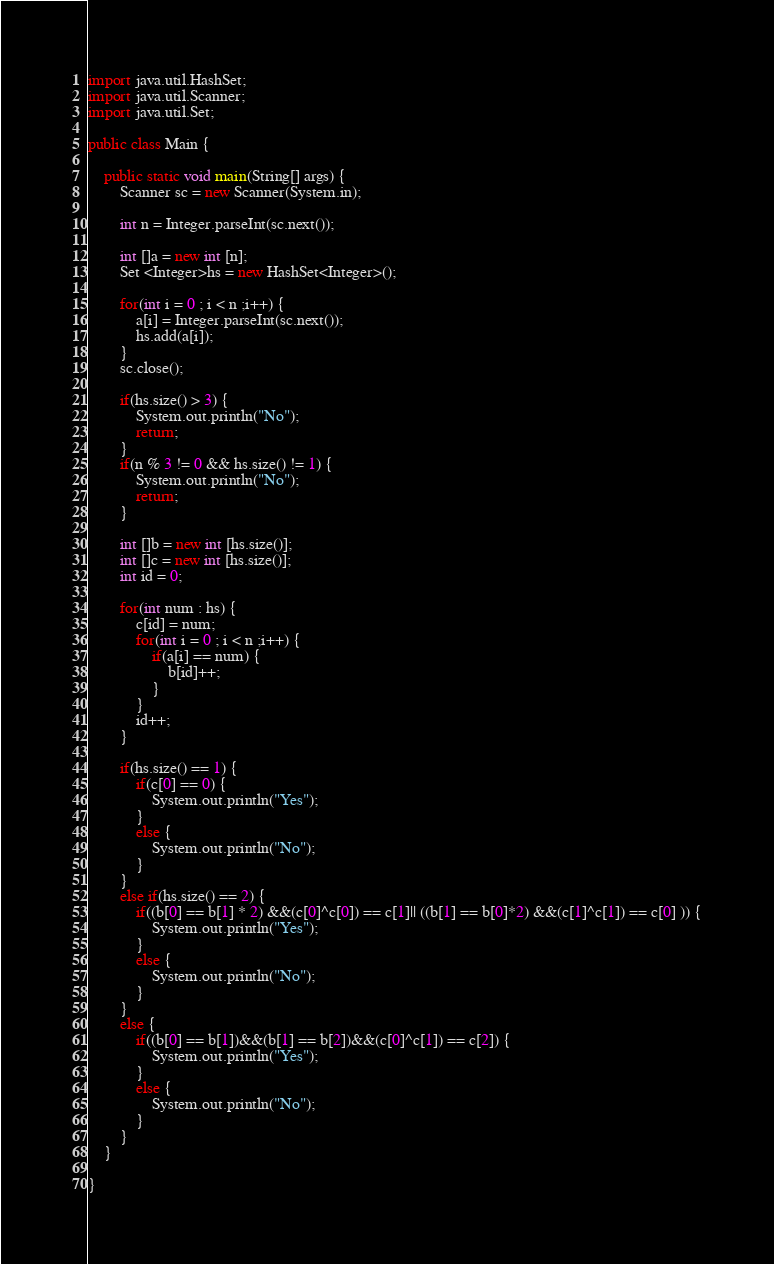Convert code to text. <code><loc_0><loc_0><loc_500><loc_500><_Java_>
import java.util.HashSet;
import java.util.Scanner;
import java.util.Set;

public class Main {

	public static void main(String[] args) {
		Scanner sc = new Scanner(System.in);
		
		int n = Integer.parseInt(sc.next());
		
		int []a = new int [n];
		Set <Integer>hs = new HashSet<Integer>();
		
		for(int i = 0 ; i < n ;i++) {
			a[i] = Integer.parseInt(sc.next());
			hs.add(a[i]);
		}
		sc.close();
		
		if(hs.size() > 3) {
			System.out.println("No");
			return;
		}
		if(n % 3 != 0 && hs.size() != 1) {
			System.out.println("No");
			return;
		}
		
		int []b = new int [hs.size()];
		int []c = new int [hs.size()];
		int id = 0;
		
		for(int num : hs) {
			c[id] = num;
			for(int i = 0 ; i < n ;i++) {
				if(a[i] == num) {
					b[id]++;
				}
			}
			id++;
		}
		
		if(hs.size() == 1) {
			if(c[0] == 0) {
				System.out.println("Yes");
			}
			else {
				System.out.println("No");
			}
		}
		else if(hs.size() == 2) {
			if((b[0] == b[1] * 2) &&(c[0]^c[0]) == c[1]|| ((b[1] == b[0]*2) &&(c[1]^c[1]) == c[0] )) {
				System.out.println("Yes");
			}
			else {
				System.out.println("No");
			}
		}
		else {
			if((b[0] == b[1])&&(b[1] == b[2])&&(c[0]^c[1]) == c[2]) {
				System.out.println("Yes");
			}
			else {
				System.out.println("No");
			}
		}
	}

}
</code> 